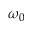<formula> <loc_0><loc_0><loc_500><loc_500>\omega _ { 0 }</formula> 